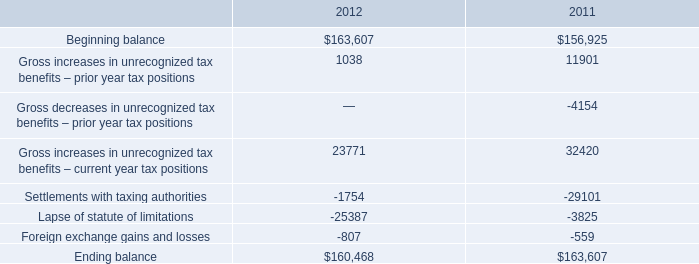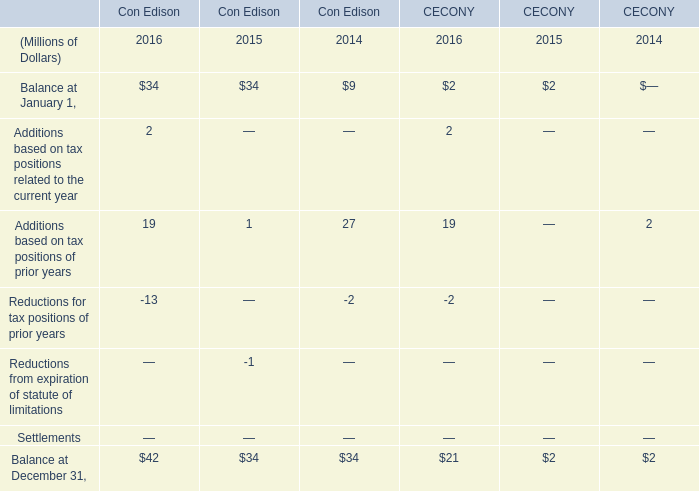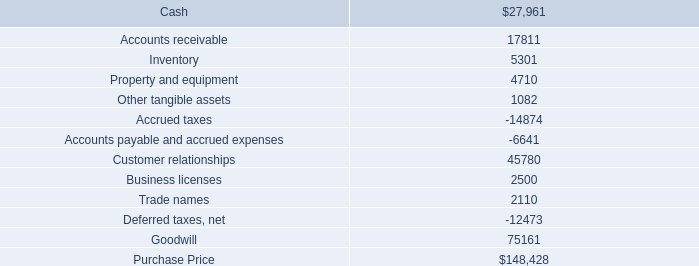What will Balance at December 31 in Con Edison be like in 2017 if it develops with the same increasing rate as current? (in millions) 
Computations: ((1 + ((42 - 34) / 34)) * 42)
Answer: 51.88235. 